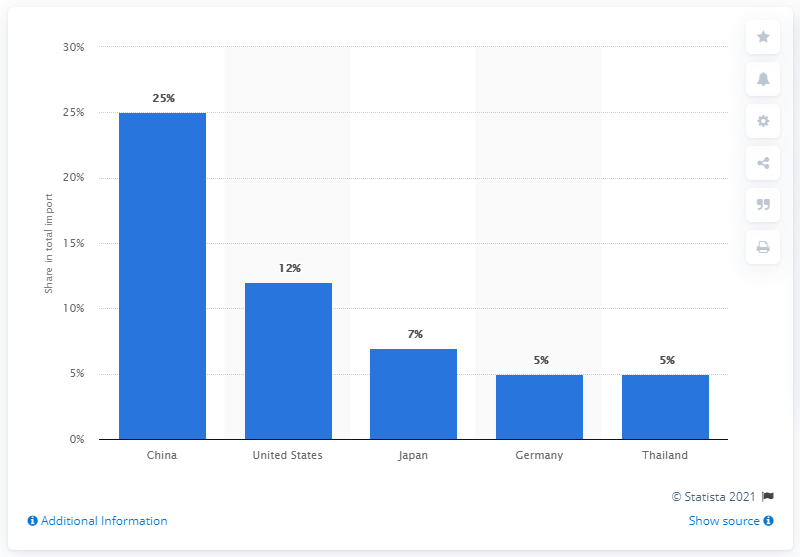Identify some key points in this picture. Australia's most important import partner is China. Australia's most important import partner is China. 